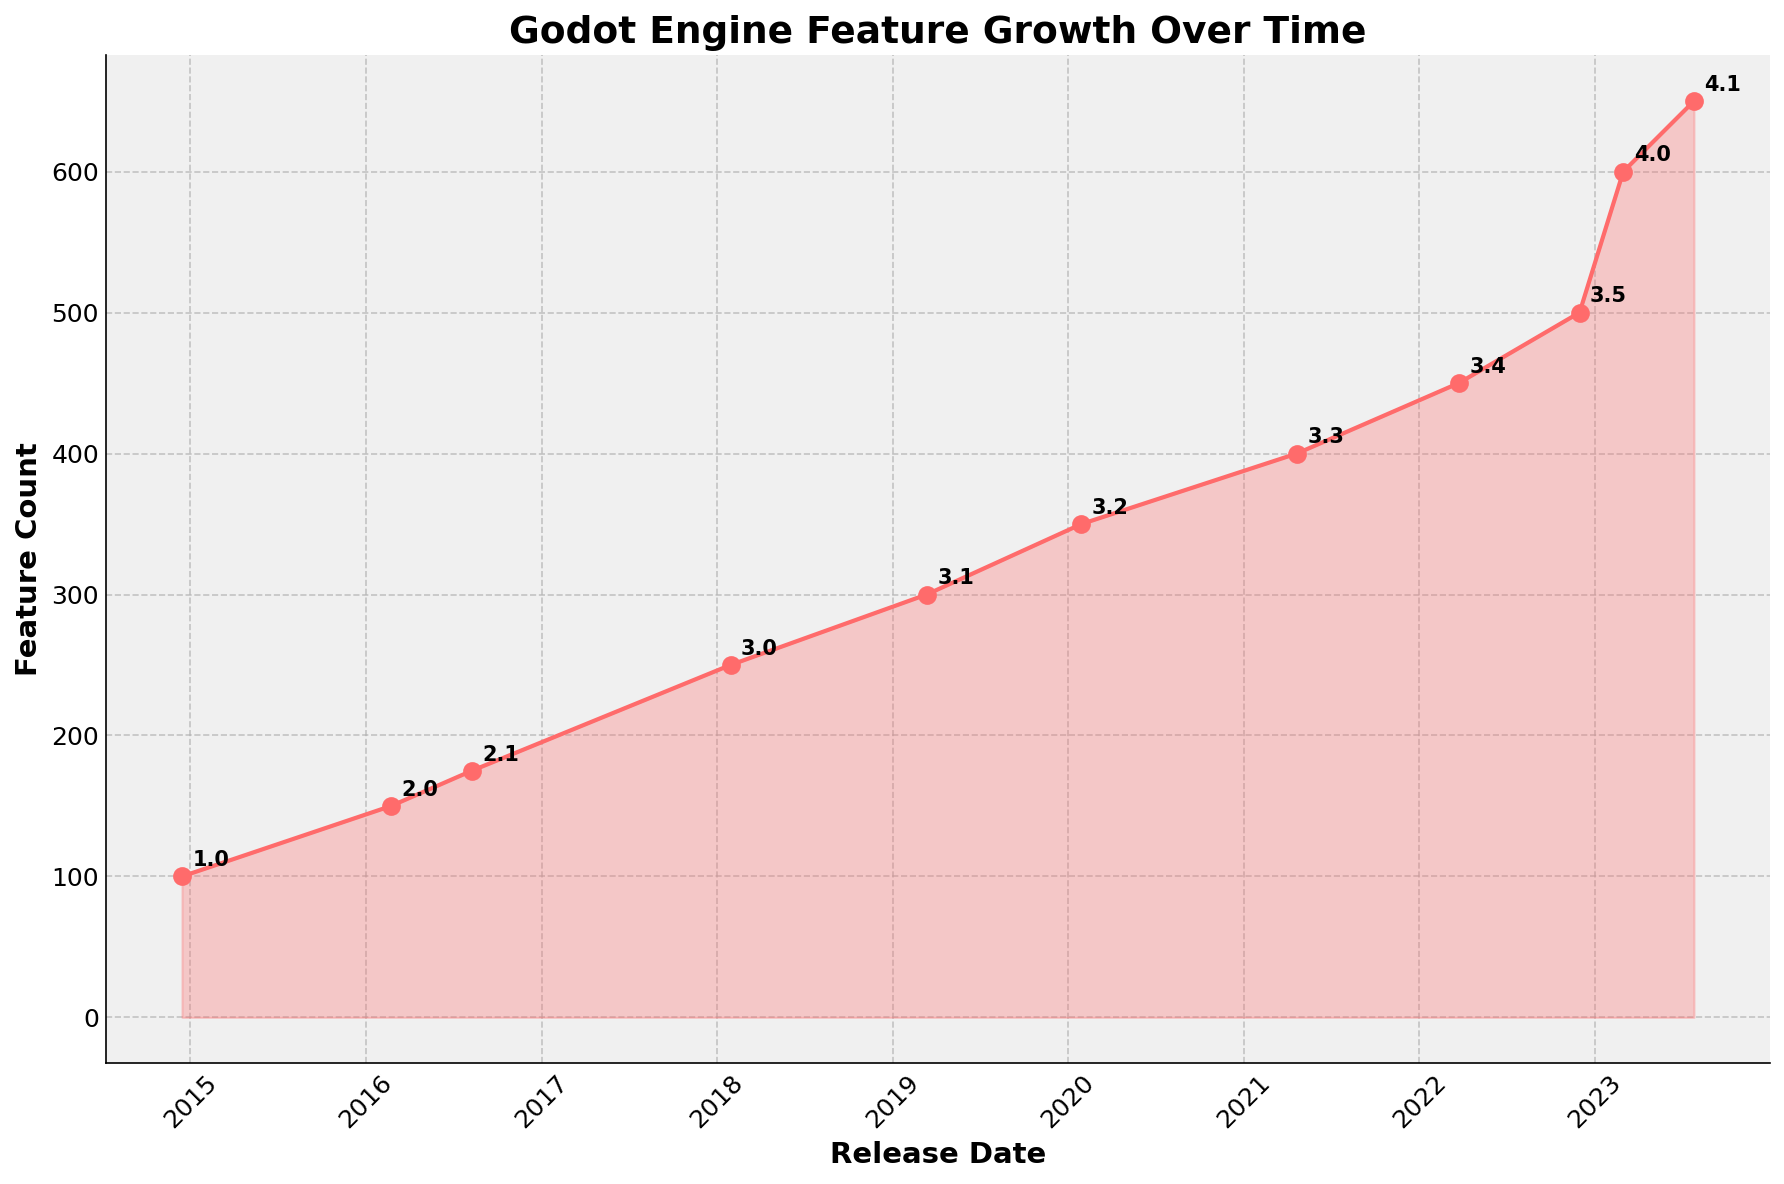Which version had the highest feature count? By looking at the highest point marked on the y-axis representing the feature count, the version annotated at that point is 4.1.
Answer: 4.1 How much time passed between the releases of versions 2.0 and 3.0? By finding the release dates of versions 2.0 (2016-02-23) and 3.0 (2018-01-29), then calculating the difference between these dates, approximately 1 year and 11 months have passed.
Answer: 1 year and 11 months Which version had more features, 3.2 or 3.3? Comparing features count for versions 3.2 (350) and 3.3 (400), 3.3 has more features.
Answer: 3.3 What is the total feature increase from version 3.1 to 4.1? By calculating the difference in feature count between versions 3.1 (300) and 4.1 (650), the increase is 650 - 300 = 350.
Answer: 350 Which year had the most version releases? By observing the timeline and counting the number of releases per year, 2022 had the most with two releases: 3.4 and 3.5.
Answer: 2022 Between which two consecutive versions was the largest increase in features? Comparing the differences in feature count between each consecutive version, the largest increase is between 3.5 (500) and 4.0 (600), an increase of 100 features.
Answer: Between 3.5 and 4.0 How many months were there between the release of version 2.1 and version 3.0? By noting the release dates of versions 2.1 (2016-08-09) and 3.0 (2018-01-29), and calculating the months between the dates, it results in approximately 17 months.
Answer: 17 months Does the feature count increase consistently with each version release? By observing the feature count for each version, we see that the feature count consistently increases with every version release without any decreases.
Answer: Yes What is the average feature count across all the listed versions? Summing the features for all versions (100 + 150 + 175 + 250 + 300 + 350 + 400 + 450 + 500 + 600 + 650) and dividing by the number of versions (11), the average is approximately 346.
Answer: 346 What is the percentage increase in features from version 1.0 to version 4.1? Calculating the percentage increase: ((650 - 100) / 100) * 100%, which results in a 550% increase.
Answer: 550% 